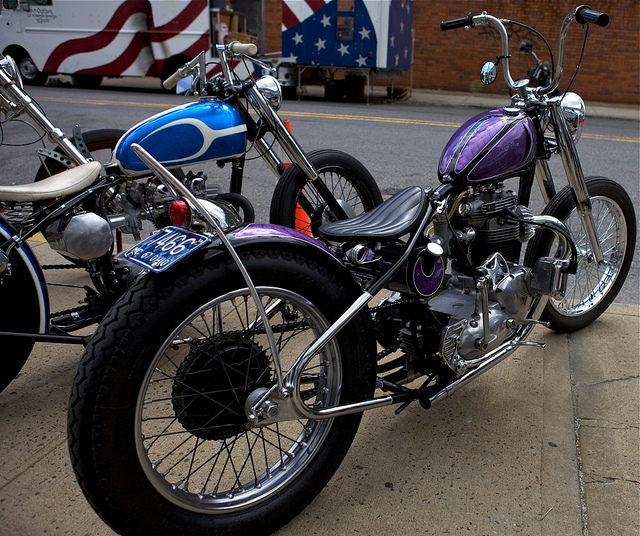<image>Do the owners of these vehicles own helmets? It is ambiguous whether the owners of these vehicles own helmets or not. What type of motorcycle is the people one? I don't know what type of motorcycle the people are on. It could be an Indian or Harley Davidson. Do the owners of these vehicles own helmets? I don't know if the owners of these vehicles own helmets. It can be both yes and no. What type of motorcycle is the people one? I don't know what type of motorcycle the people on the image are riding. It can be both Indian or Harley Davidson. 